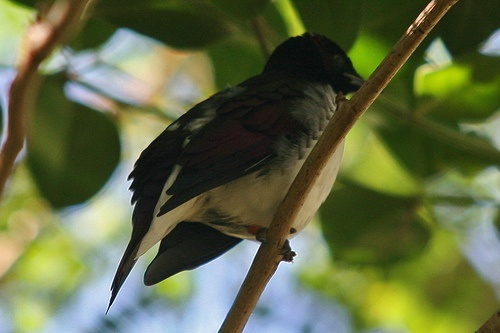Describe the objects in this image and their specific colors. I can see a bird in khaki, black, darkgreen, tan, and gray tones in this image. 